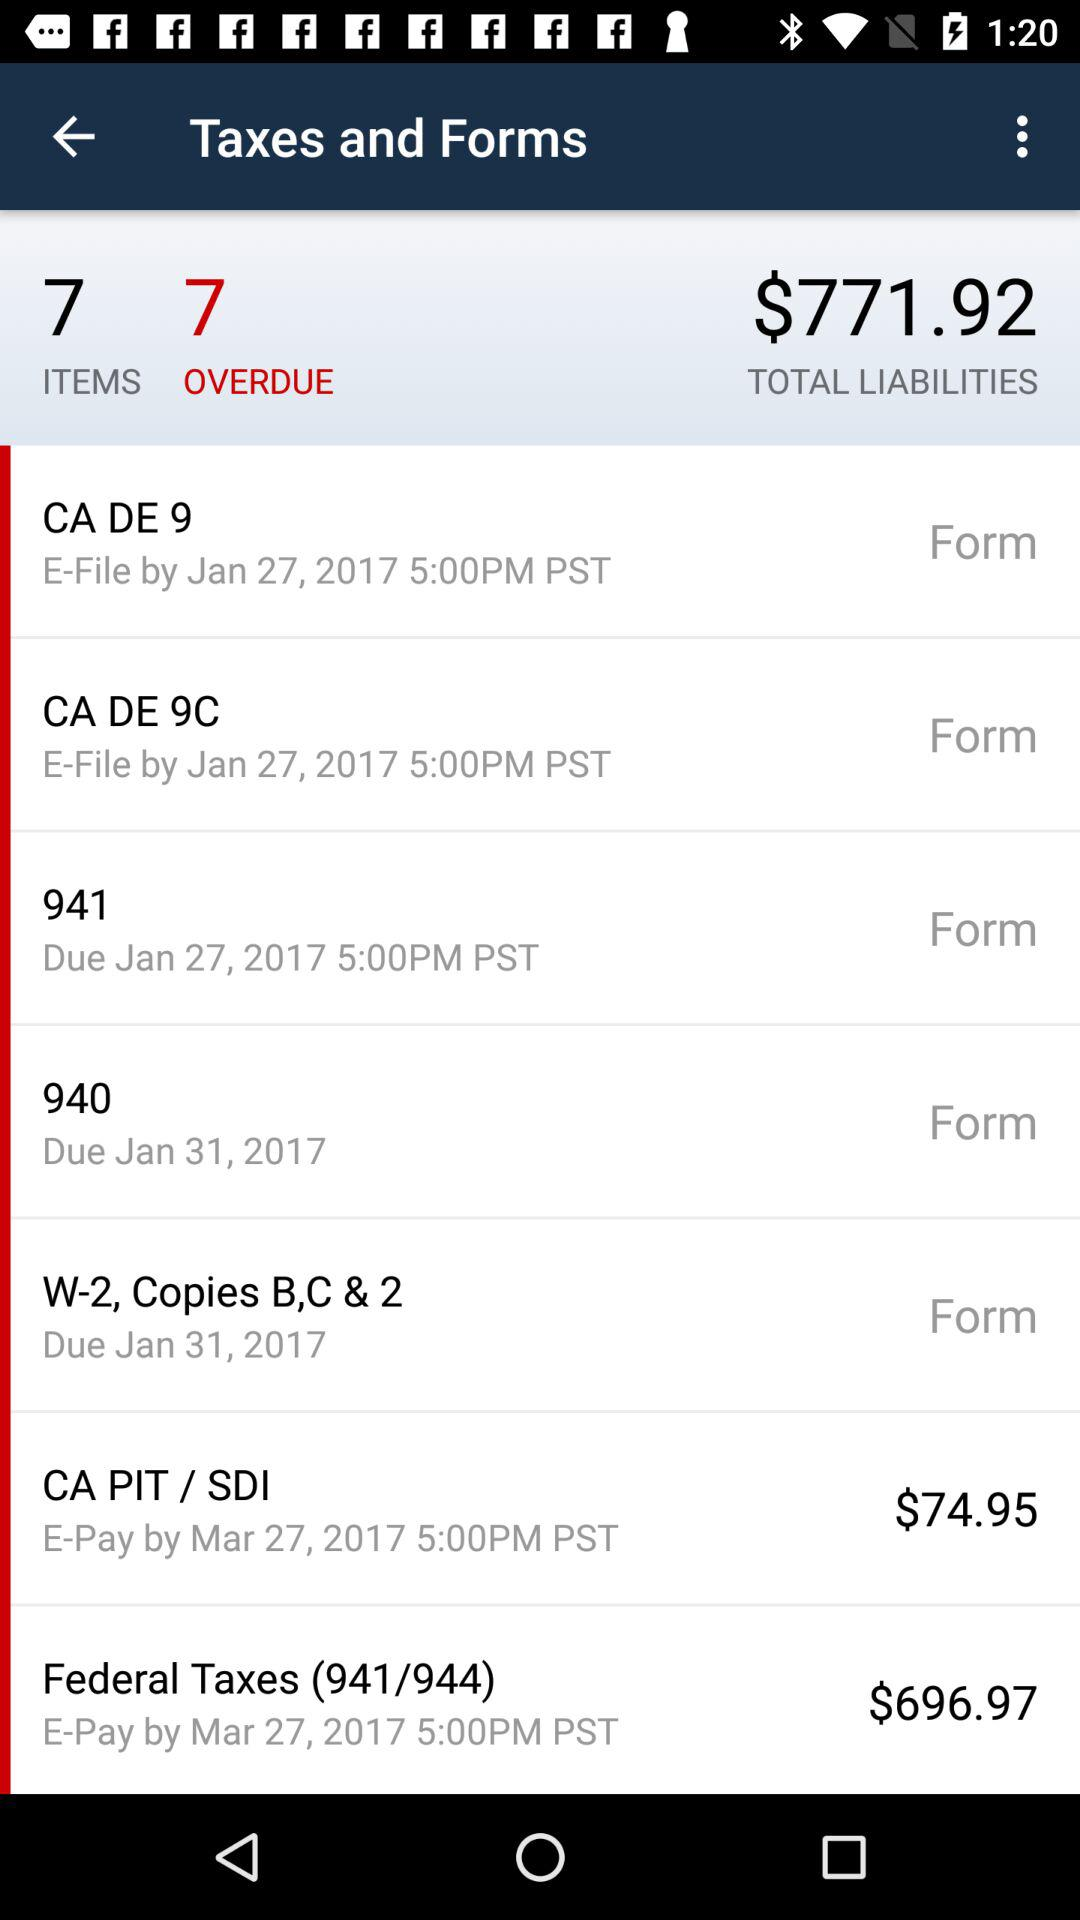What are the federal taxes? The federal tax is $696.97. 